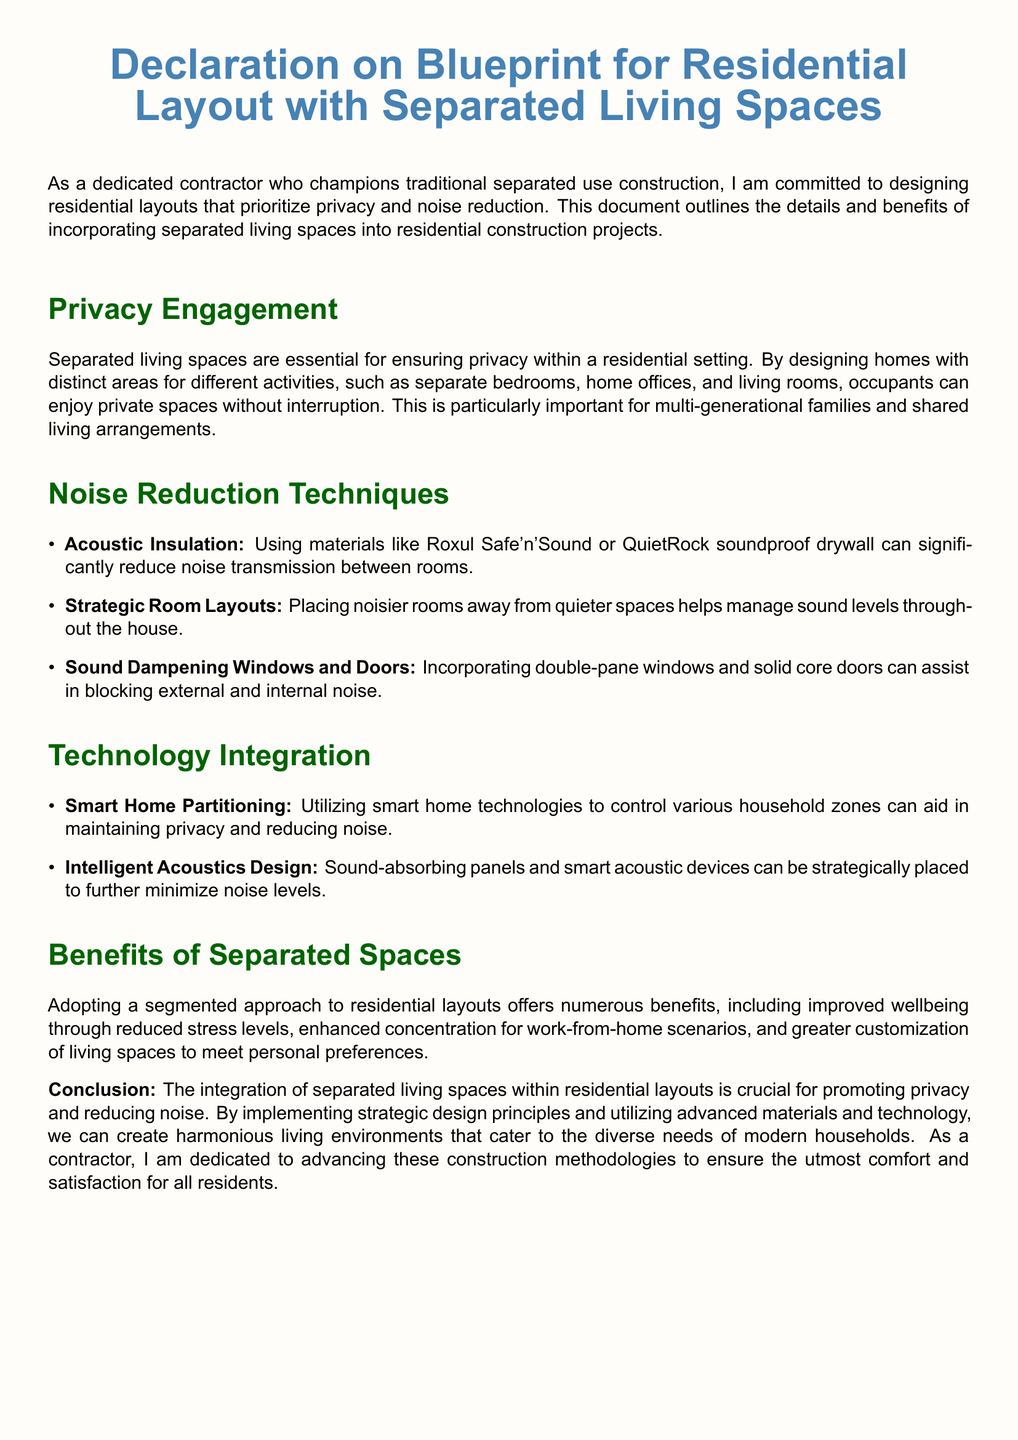What is the title of the document? The title is stated at the top of the document and is highlighted.
Answer: Declaration on Blueprint for Residential Layout with Separated Living Spaces What type of construction does the author advocate for? The document describes the author's commitment to a specific type of residential design.
Answer: Traditional separated use construction Which material is mentioned for acoustic insulation? The document lists specific materials that can be used for soundproofing in residential layouts.
Answer: Roxul Safe'n'Sound What is one benefit of adopting separated living spaces? The document identifies various advantages related to psychological and functional aspects of living arrangements.
Answer: Improved wellbeing What technology is mentioned for maintaining privacy in the document? The author discusses the role of certain advanced technologies in enhancing living environments.
Answer: Smart home technologies How many noise reduction techniques are listed? The document contains a section that enumerates approaches to minimize noise, indicating a specific count.
Answer: Three Which section addresses the benefits of separated spaces? The layout of the document organizes content into thematically different segments.
Answer: Benefits of Separated Spaces What can aid in blocking external noise as per the document? The document highlights specific building elements designed to mitigate various forms of noise pollution.
Answer: Sound Dampening Windows and Doors What is the primary focus of the document? The introduction outlines the main theme and aims of the declaration, emphasizing a certain design principle.
Answer: Privacy and noise reduction 